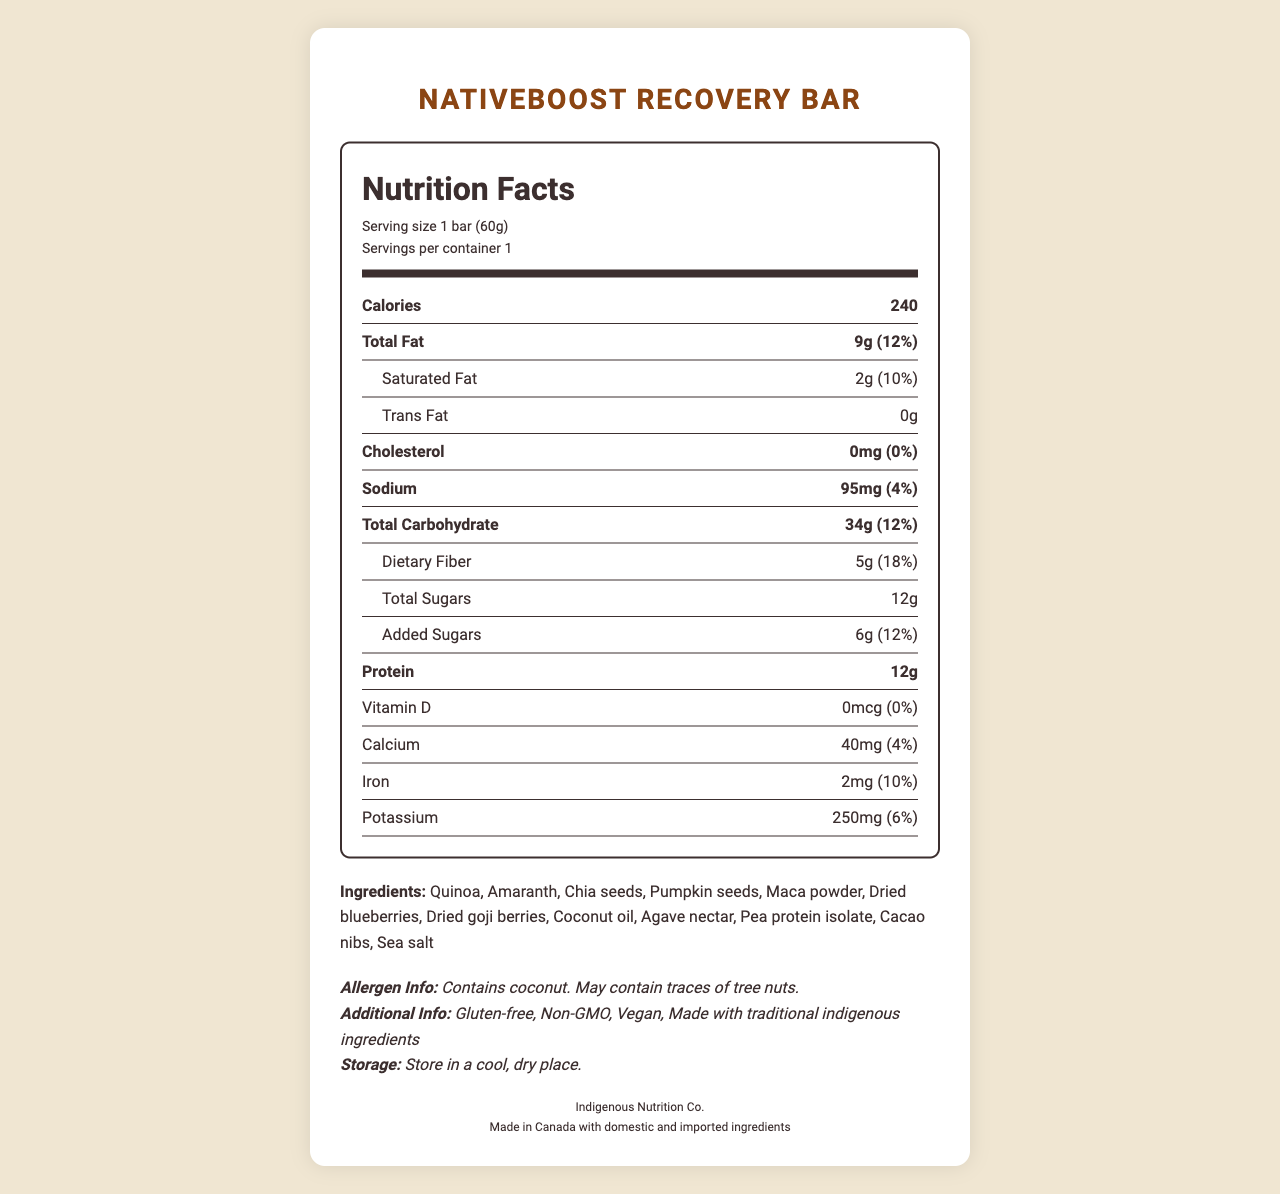What is the serving size of the NativeBoost Recovery Bar? The serving size is clearly mentioned at the start of the document, under the product name and servings per container.
Answer: 1 bar (60g) How many calories are in one NativeBoost Recovery Bar? The number of calories is listed prominently in the nutrition facts section.
Answer: 240 How much total fat does the bar contain? The total fat content is listed under the nutrition facts, with both amount in grams and daily value percentage provided.
Answer: 9g (12%) Does the bar contain any cholesterol? The document states that the cholesterol content is 0mg, which is 0% of the daily value.
Answer: No What are the protein and fiber contents of the bar? Both protein and dietary fiber contents are listed in the nutrition facts, with dietary fiber including its daily value percentage.
Answer: 12g protein, 5g dietary fiber (18%) List the main ingredients of the NativeBoost Recovery Bar. The ingredients section lists all the main ingredients of the bar.
Answer: Quinoa, Amaranth, Chia seeds, Pumpkin seeds, Maca powder, Dried blueberries, Dried goji berries, Coconut oil, Agave nectar, Pea protein isolate, Cacao nibs, Sea salt How much added sugar is in the bar? A. 0g B. 3g C. 6g D. 12g The amount of added sugars is mentioned specifically as 6g in the nutrition facts section.
Answer: C. 6g Which of the following minerals is present in the highest amount in the bar? (Daily Value %) i. Calcium ii. Iron iii. Potassium Iron has a daily value percentage of 10%, higher than calcium (4%) and potassium (6%).
Answer: ii. Iron Is the NativeBoost Recovery Bar gluten-free? The additional information section states that the bar is gluten-free.
Answer: Yes Summarize the main highlights and nutrition of the NativeBoost Recovery Bar. This summary includes key metrics such as serving size, calorie content, macronutrients, ingredients, and additional product info.
Answer: The NativeBoost Recovery Bar, produced by Indigenous Nutrition Co. and made in Canada, is a 60g bar designed for post-workout recovery. It contains 240 calories, 9g of fat, 34g of carbohydrates, 12g of protein, and 5g of fiber. Ingredients include ancient grains and native superfoods like quinoa, amaranth, chia seeds, and maca powder. It is gluten-free, non-GMO, vegan, and uses traditional indigenous ingredients. Can you eat this bar if you have a peanut allergy? The document states it may contain traces of tree nuts but does not specifically mention peanuts. Therefore, there isn’t enough information to safely determine if it is suitable for someone with a peanut allergy.
Answer: Not enough information Who is the manufacturer of the NativeBoost Recovery Bar? The name of the manufacturer is mentioned towards the end of the document under additional info.
Answer: Indigenous Nutrition Co. Where is the NativeBoost Recovery Bar made? This information is provided at the end of the document under the origin section.
Answer: Made in Canada with domestic and imported ingredients How much sodium does the bar contain? A. 45mg B. 75mg C. 95mg D. 125mg The sodium content is clearly marked as 95mg in the nutrition facts section.
Answer: C. 95mg Does the bar contain any vitamin D? The nutrition facts indicate that the amount of vitamin D is 0mcg, which is 0% of the daily value.
Answer: No 